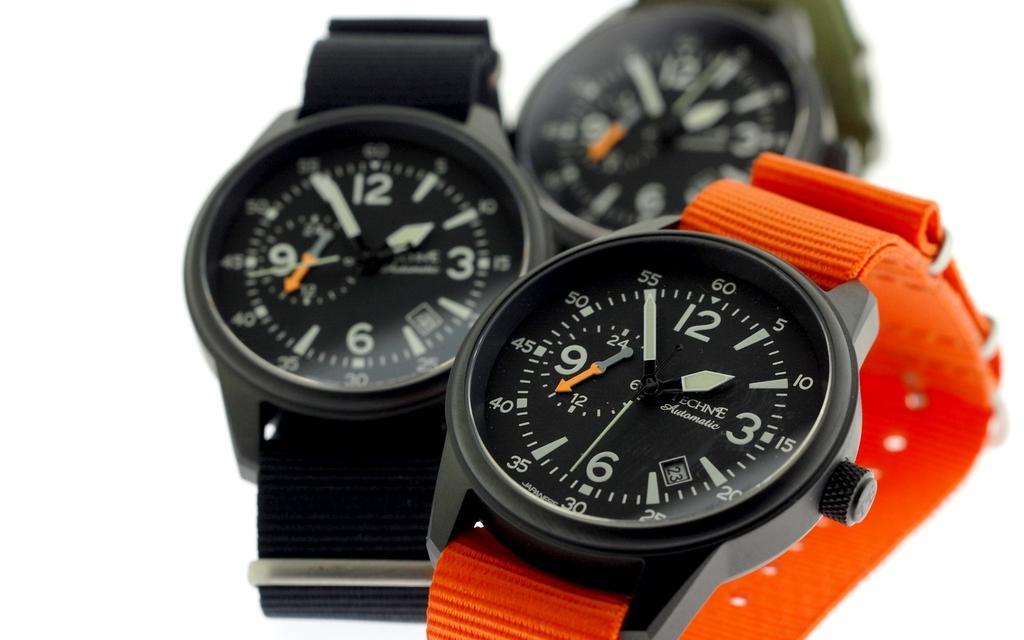Could you give a brief overview of what you see in this image? In this image we can see watches. In the background it is white. 